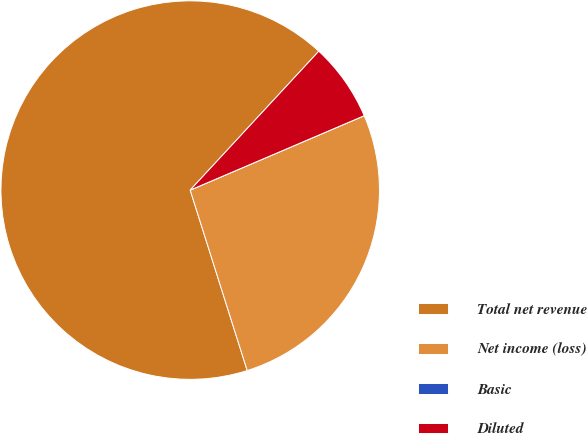Convert chart to OTSL. <chart><loc_0><loc_0><loc_500><loc_500><pie_chart><fcel>Total net revenue<fcel>Net income (loss)<fcel>Basic<fcel>Diluted<nl><fcel>66.76%<fcel>26.56%<fcel>0.0%<fcel>6.68%<nl></chart> 